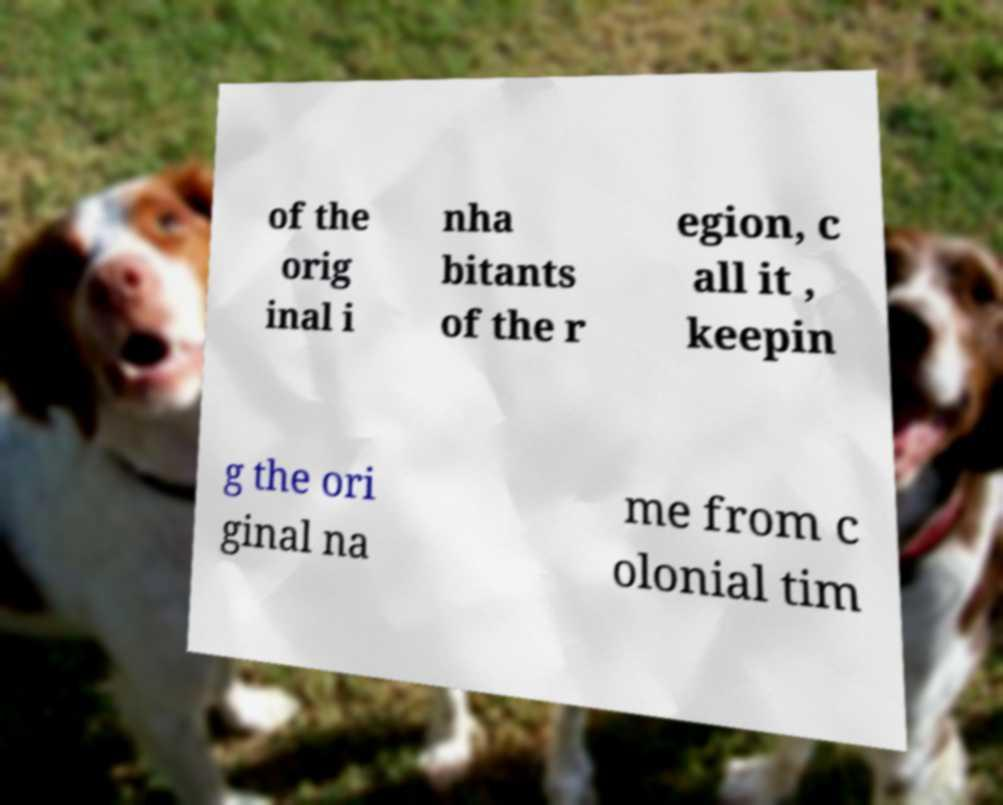Please identify and transcribe the text found in this image. of the orig inal i nha bitants of the r egion, c all it , keepin g the ori ginal na me from c olonial tim 